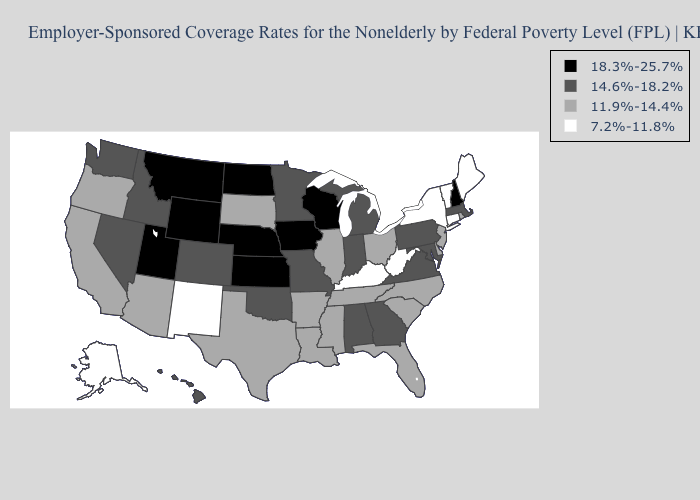What is the value of Nebraska?
Concise answer only. 18.3%-25.7%. What is the lowest value in the South?
Give a very brief answer. 7.2%-11.8%. Is the legend a continuous bar?
Short answer required. No. Name the states that have a value in the range 11.9%-14.4%?
Write a very short answer. Arizona, Arkansas, California, Delaware, Florida, Illinois, Louisiana, Mississippi, New Jersey, North Carolina, Ohio, Oregon, Rhode Island, South Carolina, South Dakota, Tennessee, Texas. Among the states that border South Dakota , does Wyoming have the lowest value?
Give a very brief answer. No. Name the states that have a value in the range 11.9%-14.4%?
Give a very brief answer. Arizona, Arkansas, California, Delaware, Florida, Illinois, Louisiana, Mississippi, New Jersey, North Carolina, Ohio, Oregon, Rhode Island, South Carolina, South Dakota, Tennessee, Texas. Among the states that border California , which have the highest value?
Short answer required. Nevada. Among the states that border Oklahoma , which have the lowest value?
Answer briefly. New Mexico. What is the lowest value in states that border South Dakota?
Quick response, please. 14.6%-18.2%. What is the lowest value in the South?
Give a very brief answer. 7.2%-11.8%. Does Maine have the highest value in the Northeast?
Short answer required. No. What is the lowest value in the USA?
Concise answer only. 7.2%-11.8%. What is the value of New Hampshire?
Write a very short answer. 18.3%-25.7%. Name the states that have a value in the range 11.9%-14.4%?
Keep it brief. Arizona, Arkansas, California, Delaware, Florida, Illinois, Louisiana, Mississippi, New Jersey, North Carolina, Ohio, Oregon, Rhode Island, South Carolina, South Dakota, Tennessee, Texas. What is the highest value in states that border California?
Be succinct. 14.6%-18.2%. 